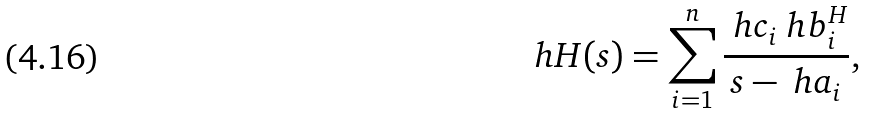<formula> <loc_0><loc_0><loc_500><loc_500>\ h H ( s ) = \sum _ { i = 1 } ^ { n } \frac { \ h c _ { i } \ h b _ { i } ^ { H } } { s - \ h a _ { i } } ,</formula> 